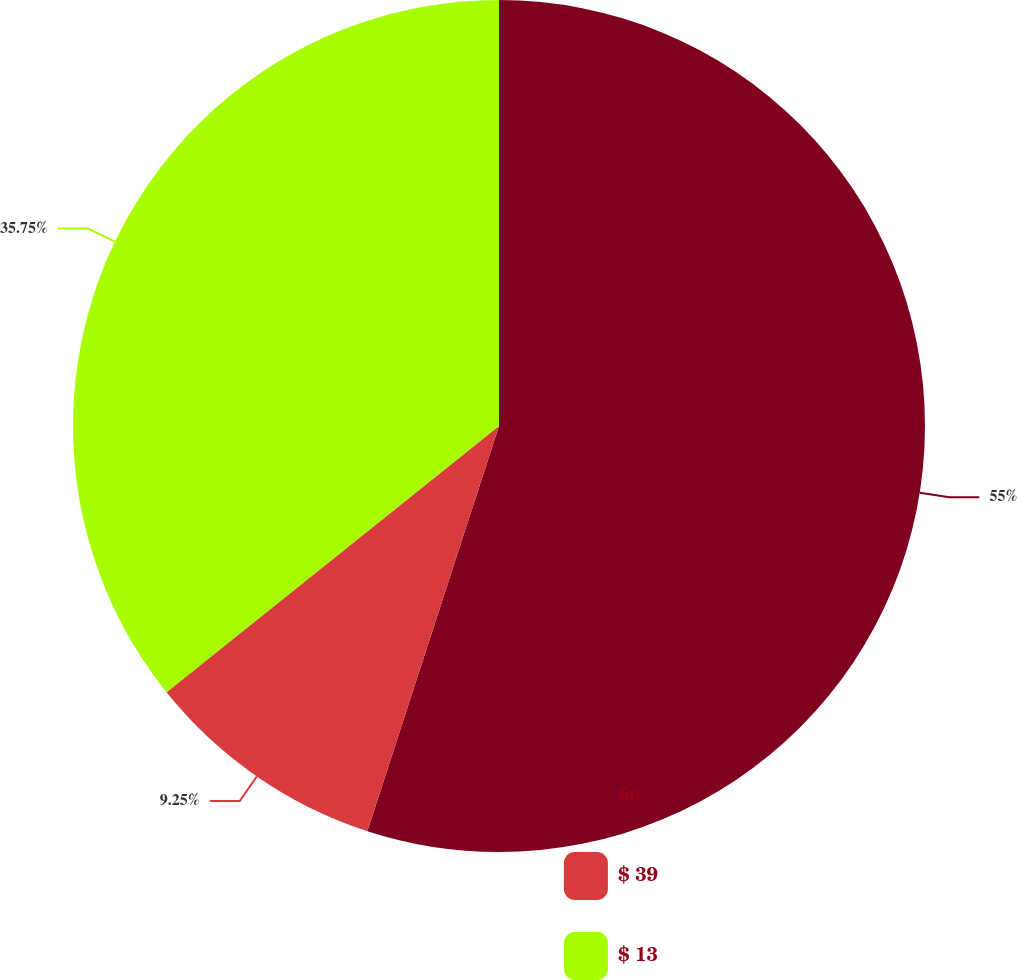Convert chart. <chart><loc_0><loc_0><loc_500><loc_500><pie_chart><fcel>60<fcel>$ 39<fcel>$ 13<nl><fcel>55.0%<fcel>9.25%<fcel>35.75%<nl></chart> 